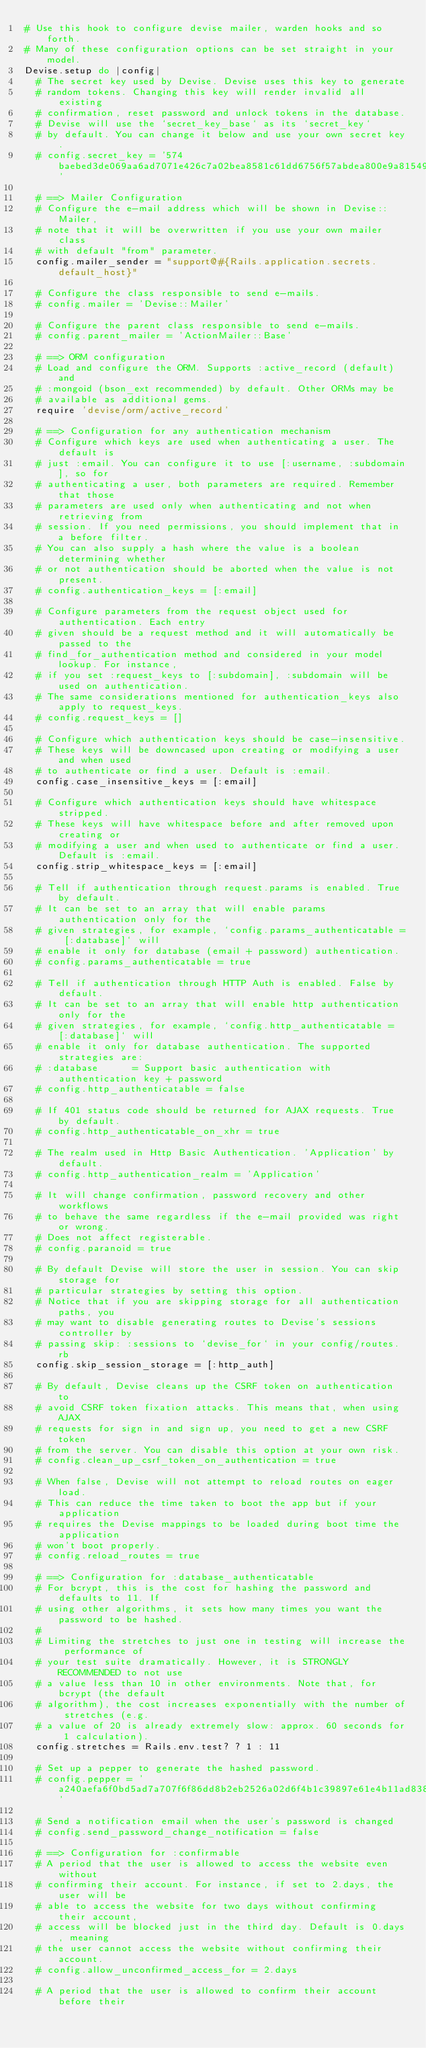Convert code to text. <code><loc_0><loc_0><loc_500><loc_500><_Ruby_># Use this hook to configure devise mailer, warden hooks and so forth.
# Many of these configuration options can be set straight in your model.
Devise.setup do |config|
  # The secret key used by Devise. Devise uses this key to generate
  # random tokens. Changing this key will render invalid all existing
  # confirmation, reset password and unlock tokens in the database.
  # Devise will use the `secret_key_base` as its `secret_key`
  # by default. You can change it below and use your own secret key.
  # config.secret_key = '574baebed3de069aa6ad7071e426c7a02bea8581c61dd6756f57abdea800e9a8154996d6612390c5d943acc5612b3e01b0bfe00f38b8380c345080e04d1b1aba'

  # ==> Mailer Configuration
  # Configure the e-mail address which will be shown in Devise::Mailer,
  # note that it will be overwritten if you use your own mailer class
  # with default "from" parameter.
  config.mailer_sender = "support@#{Rails.application.secrets.default_host}"

  # Configure the class responsible to send e-mails.
  # config.mailer = 'Devise::Mailer'

  # Configure the parent class responsible to send e-mails.
  # config.parent_mailer = 'ActionMailer::Base'

  # ==> ORM configuration
  # Load and configure the ORM. Supports :active_record (default) and
  # :mongoid (bson_ext recommended) by default. Other ORMs may be
  # available as additional gems.
  require 'devise/orm/active_record'

  # ==> Configuration for any authentication mechanism
  # Configure which keys are used when authenticating a user. The default is
  # just :email. You can configure it to use [:username, :subdomain], so for
  # authenticating a user, both parameters are required. Remember that those
  # parameters are used only when authenticating and not when retrieving from
  # session. If you need permissions, you should implement that in a before filter.
  # You can also supply a hash where the value is a boolean determining whether
  # or not authentication should be aborted when the value is not present.
  # config.authentication_keys = [:email]

  # Configure parameters from the request object used for authentication. Each entry
  # given should be a request method and it will automatically be passed to the
  # find_for_authentication method and considered in your model lookup. For instance,
  # if you set :request_keys to [:subdomain], :subdomain will be used on authentication.
  # The same considerations mentioned for authentication_keys also apply to request_keys.
  # config.request_keys = []

  # Configure which authentication keys should be case-insensitive.
  # These keys will be downcased upon creating or modifying a user and when used
  # to authenticate or find a user. Default is :email.
  config.case_insensitive_keys = [:email]

  # Configure which authentication keys should have whitespace stripped.
  # These keys will have whitespace before and after removed upon creating or
  # modifying a user and when used to authenticate or find a user. Default is :email.
  config.strip_whitespace_keys = [:email]

  # Tell if authentication through request.params is enabled. True by default.
  # It can be set to an array that will enable params authentication only for the
  # given strategies, for example, `config.params_authenticatable = [:database]` will
  # enable it only for database (email + password) authentication.
  # config.params_authenticatable = true

  # Tell if authentication through HTTP Auth is enabled. False by default.
  # It can be set to an array that will enable http authentication only for the
  # given strategies, for example, `config.http_authenticatable = [:database]` will
  # enable it only for database authentication. The supported strategies are:
  # :database      = Support basic authentication with authentication key + password
  # config.http_authenticatable = false

  # If 401 status code should be returned for AJAX requests. True by default.
  # config.http_authenticatable_on_xhr = true

  # The realm used in Http Basic Authentication. 'Application' by default.
  # config.http_authentication_realm = 'Application'

  # It will change confirmation, password recovery and other workflows
  # to behave the same regardless if the e-mail provided was right or wrong.
  # Does not affect registerable.
  # config.paranoid = true

  # By default Devise will store the user in session. You can skip storage for
  # particular strategies by setting this option.
  # Notice that if you are skipping storage for all authentication paths, you
  # may want to disable generating routes to Devise's sessions controller by
  # passing skip: :sessions to `devise_for` in your config/routes.rb
  config.skip_session_storage = [:http_auth]

  # By default, Devise cleans up the CSRF token on authentication to
  # avoid CSRF token fixation attacks. This means that, when using AJAX
  # requests for sign in and sign up, you need to get a new CSRF token
  # from the server. You can disable this option at your own risk.
  # config.clean_up_csrf_token_on_authentication = true

  # When false, Devise will not attempt to reload routes on eager load.
  # This can reduce the time taken to boot the app but if your application
  # requires the Devise mappings to be loaded during boot time the application
  # won't boot properly.
  # config.reload_routes = true

  # ==> Configuration for :database_authenticatable
  # For bcrypt, this is the cost for hashing the password and defaults to 11. If
  # using other algorithms, it sets how many times you want the password to be hashed.
  #
  # Limiting the stretches to just one in testing will increase the performance of
  # your test suite dramatically. However, it is STRONGLY RECOMMENDED to not use
  # a value less than 10 in other environments. Note that, for bcrypt (the default
  # algorithm), the cost increases exponentially with the number of stretches (e.g.
  # a value of 20 is already extremely slow: approx. 60 seconds for 1 calculation).
  config.stretches = Rails.env.test? ? 1 : 11

  # Set up a pepper to generate the hashed password.
  # config.pepper = 'a240aefa6f0bd5ad7a707f6f86dd8b2eb2526a02d6f4b1c39897e61e4b11ad838723bc0ef1db642127fe7c1fe88315e37f0bc0d11c9056f774709bb397023762'

  # Send a notification email when the user's password is changed
  # config.send_password_change_notification = false

  # ==> Configuration for :confirmable
  # A period that the user is allowed to access the website even without
  # confirming their account. For instance, if set to 2.days, the user will be
  # able to access the website for two days without confirming their account,
  # access will be blocked just in the third day. Default is 0.days, meaning
  # the user cannot access the website without confirming their account.
  # config.allow_unconfirmed_access_for = 2.days

  # A period that the user is allowed to confirm their account before their</code> 